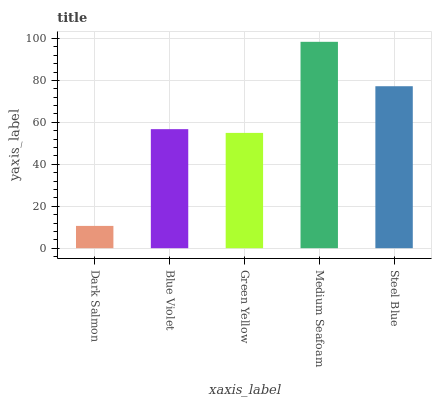Is Blue Violet the minimum?
Answer yes or no. No. Is Blue Violet the maximum?
Answer yes or no. No. Is Blue Violet greater than Dark Salmon?
Answer yes or no. Yes. Is Dark Salmon less than Blue Violet?
Answer yes or no. Yes. Is Dark Salmon greater than Blue Violet?
Answer yes or no. No. Is Blue Violet less than Dark Salmon?
Answer yes or no. No. Is Blue Violet the high median?
Answer yes or no. Yes. Is Blue Violet the low median?
Answer yes or no. Yes. Is Green Yellow the high median?
Answer yes or no. No. Is Steel Blue the low median?
Answer yes or no. No. 